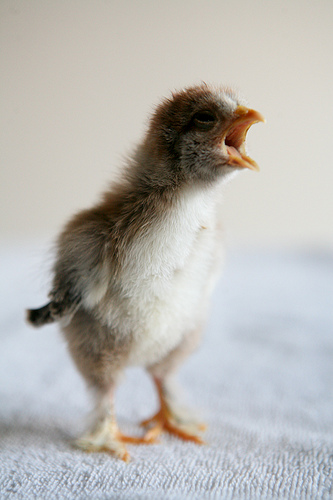<image>
Can you confirm if the bird is next to the carpet? No. The bird is not positioned next to the carpet. They are located in different areas of the scene. 